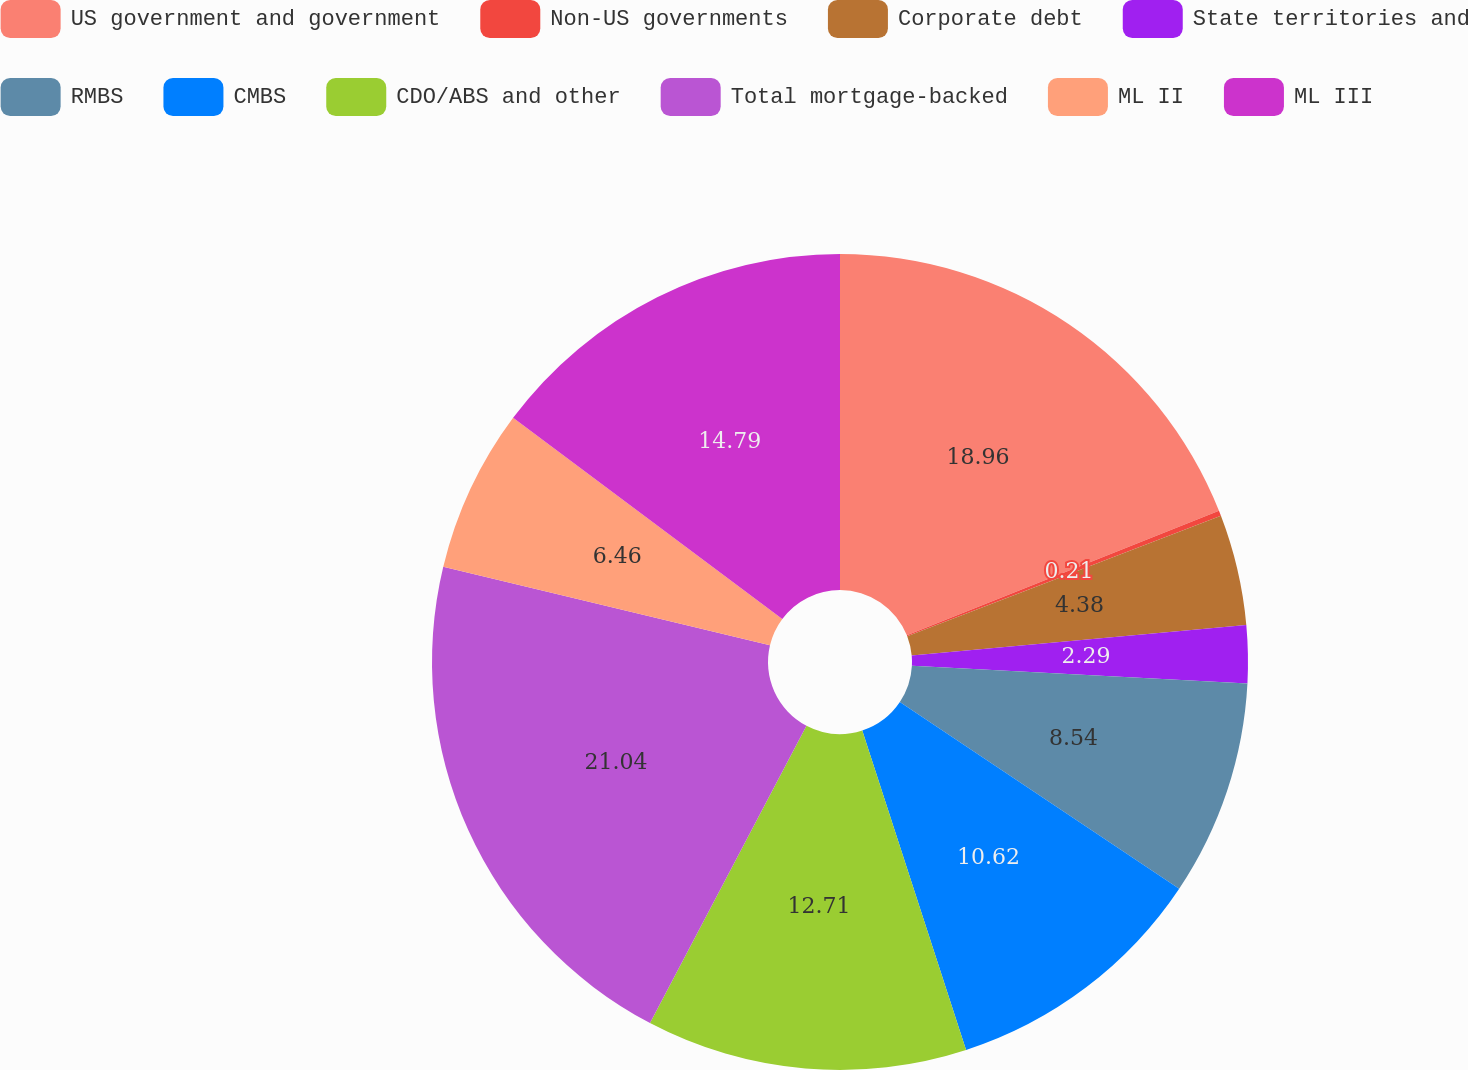Convert chart. <chart><loc_0><loc_0><loc_500><loc_500><pie_chart><fcel>US government and government<fcel>Non-US governments<fcel>Corporate debt<fcel>State territories and<fcel>RMBS<fcel>CMBS<fcel>CDO/ABS and other<fcel>Total mortgage-backed<fcel>ML II<fcel>ML III<nl><fcel>18.96%<fcel>0.21%<fcel>4.38%<fcel>2.29%<fcel>8.54%<fcel>10.62%<fcel>12.71%<fcel>21.04%<fcel>6.46%<fcel>14.79%<nl></chart> 